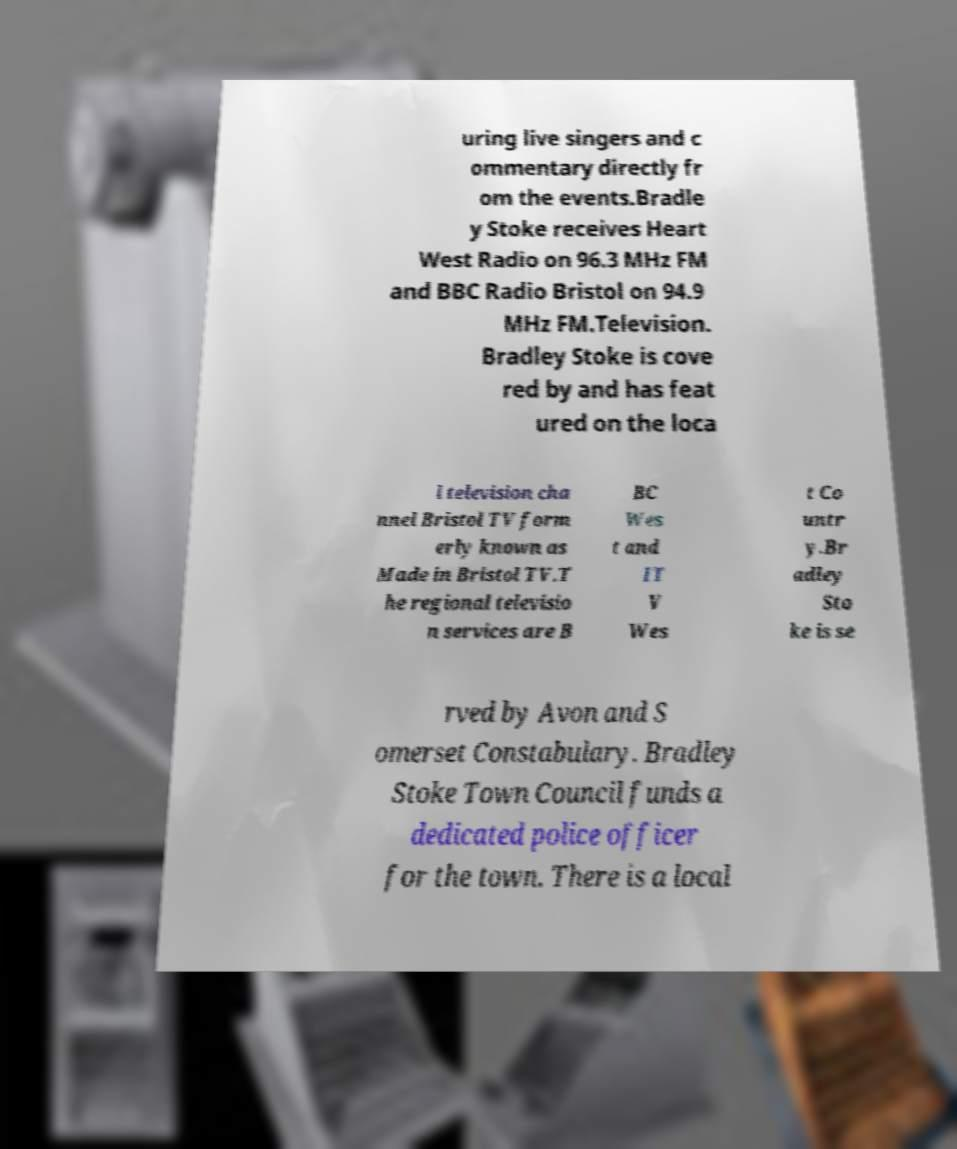For documentation purposes, I need the text within this image transcribed. Could you provide that? uring live singers and c ommentary directly fr om the events.Bradle y Stoke receives Heart West Radio on 96.3 MHz FM and BBC Radio Bristol on 94.9 MHz FM.Television. Bradley Stoke is cove red by and has feat ured on the loca l television cha nnel Bristol TV form erly known as Made in Bristol TV.T he regional televisio n services are B BC Wes t and IT V Wes t Co untr y.Br adley Sto ke is se rved by Avon and S omerset Constabulary. Bradley Stoke Town Council funds a dedicated police officer for the town. There is a local 